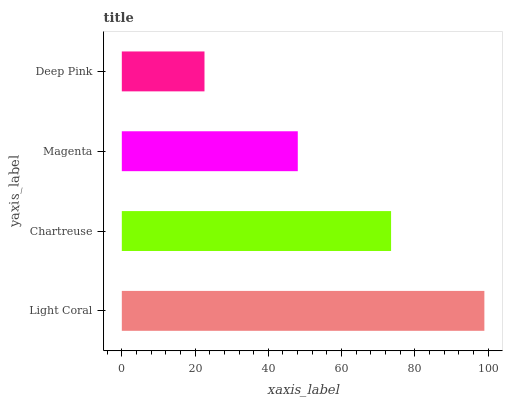Is Deep Pink the minimum?
Answer yes or no. Yes. Is Light Coral the maximum?
Answer yes or no. Yes. Is Chartreuse the minimum?
Answer yes or no. No. Is Chartreuse the maximum?
Answer yes or no. No. Is Light Coral greater than Chartreuse?
Answer yes or no. Yes. Is Chartreuse less than Light Coral?
Answer yes or no. Yes. Is Chartreuse greater than Light Coral?
Answer yes or no. No. Is Light Coral less than Chartreuse?
Answer yes or no. No. Is Chartreuse the high median?
Answer yes or no. Yes. Is Magenta the low median?
Answer yes or no. Yes. Is Light Coral the high median?
Answer yes or no. No. Is Chartreuse the low median?
Answer yes or no. No. 